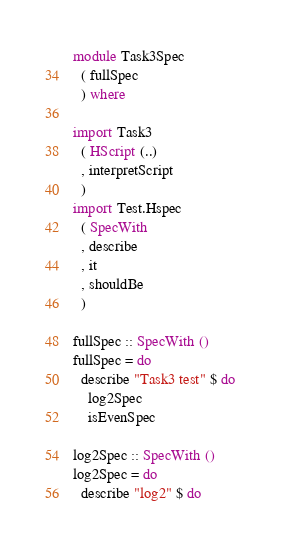<code> <loc_0><loc_0><loc_500><loc_500><_Haskell_>module Task3Spec
  ( fullSpec
  ) where

import Task3
  ( HScript (..)
  , interpretScript
  )
import Test.Hspec 
  ( SpecWith
  , describe
  , it
  , shouldBe
  )

fullSpec :: SpecWith ()
fullSpec = do
  describe "Task3 test" $ do
    log2Spec
    isEvenSpec

log2Spec :: SpecWith ()
log2Spec = do
  describe "log2" $ do</code> 